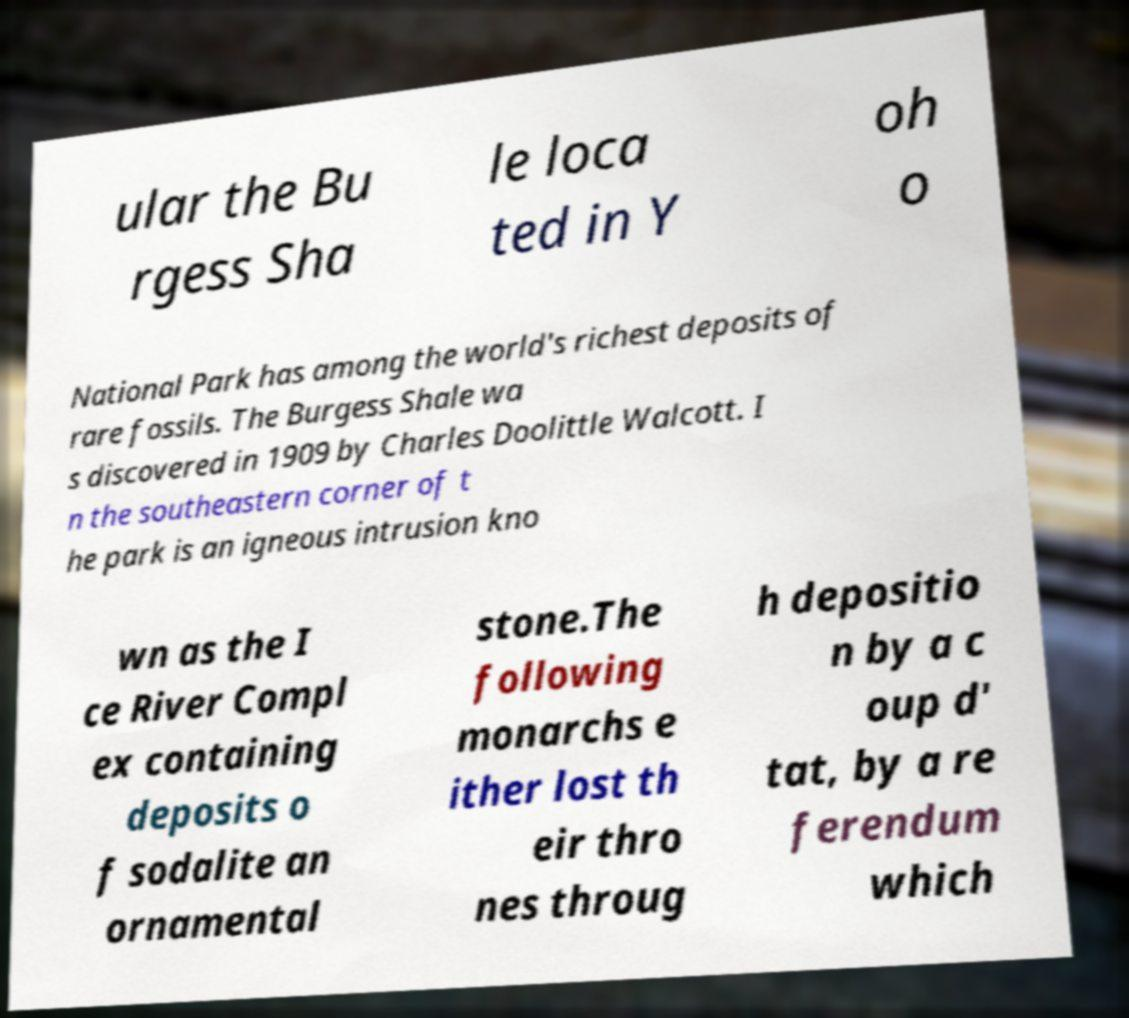Could you assist in decoding the text presented in this image and type it out clearly? ular the Bu rgess Sha le loca ted in Y oh o National Park has among the world's richest deposits of rare fossils. The Burgess Shale wa s discovered in 1909 by Charles Doolittle Walcott. I n the southeastern corner of t he park is an igneous intrusion kno wn as the I ce River Compl ex containing deposits o f sodalite an ornamental stone.The following monarchs e ither lost th eir thro nes throug h depositio n by a c oup d' tat, by a re ferendum which 